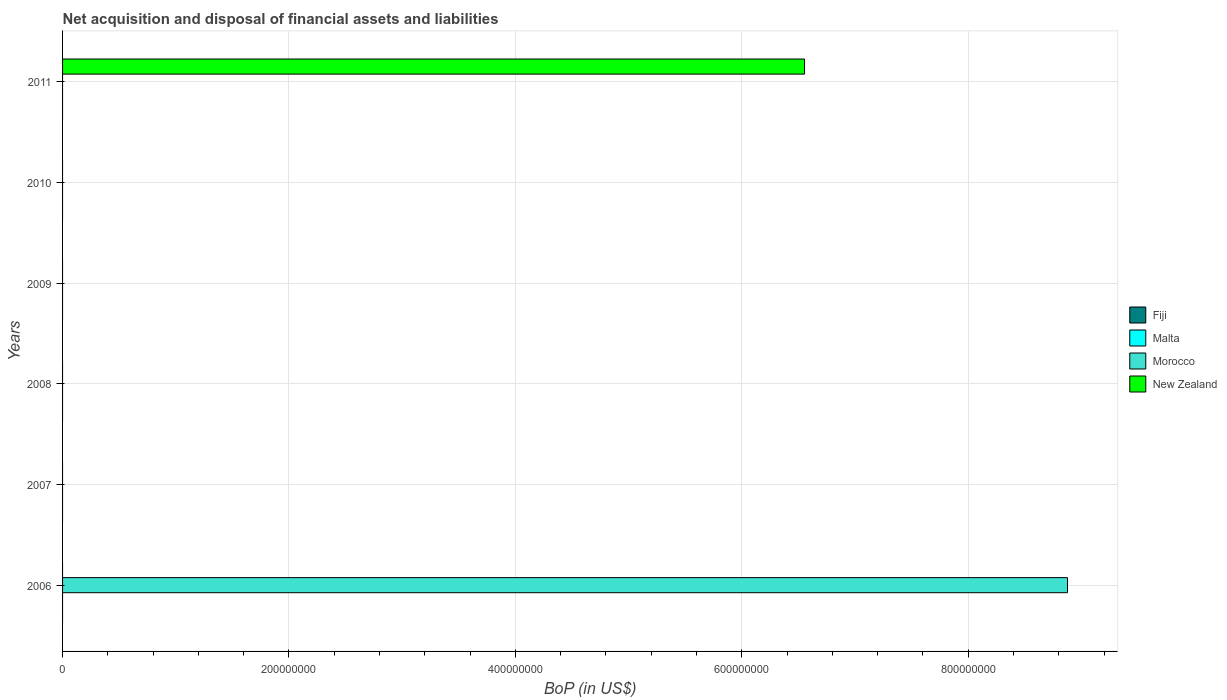How many different coloured bars are there?
Provide a succinct answer. 2. Are the number of bars per tick equal to the number of legend labels?
Offer a terse response. No. How many bars are there on the 6th tick from the top?
Provide a succinct answer. 1. Across all years, what is the maximum Balance of Payments in Morocco?
Your answer should be compact. 8.88e+08. Across all years, what is the minimum Balance of Payments in Morocco?
Offer a very short reply. 0. What is the total Balance of Payments in Morocco in the graph?
Your answer should be compact. 8.88e+08. What is the difference between the Balance of Payments in Morocco in 2011 and the Balance of Payments in Fiji in 2008?
Offer a very short reply. 0. What is the average Balance of Payments in Fiji per year?
Offer a very short reply. 0. In how many years, is the Balance of Payments in Malta greater than 840000000 US$?
Offer a terse response. 0. What is the difference between the highest and the lowest Balance of Payments in New Zealand?
Keep it short and to the point. 6.55e+08. What is the difference between two consecutive major ticks on the X-axis?
Your answer should be very brief. 2.00e+08. Does the graph contain grids?
Your answer should be compact. Yes. How many legend labels are there?
Make the answer very short. 4. What is the title of the graph?
Provide a succinct answer. Net acquisition and disposal of financial assets and liabilities. What is the label or title of the X-axis?
Your answer should be very brief. BoP (in US$). What is the label or title of the Y-axis?
Provide a succinct answer. Years. What is the BoP (in US$) in Fiji in 2006?
Ensure brevity in your answer.  0. What is the BoP (in US$) in Malta in 2006?
Your answer should be very brief. 0. What is the BoP (in US$) in Morocco in 2006?
Make the answer very short. 8.88e+08. What is the BoP (in US$) in New Zealand in 2006?
Offer a very short reply. 0. What is the BoP (in US$) in Malta in 2007?
Offer a very short reply. 0. What is the BoP (in US$) of Fiji in 2008?
Your response must be concise. 0. What is the BoP (in US$) of New Zealand in 2008?
Your answer should be very brief. 0. What is the BoP (in US$) of Malta in 2009?
Offer a terse response. 0. What is the BoP (in US$) in Morocco in 2009?
Give a very brief answer. 0. What is the BoP (in US$) of New Zealand in 2009?
Offer a terse response. 0. What is the BoP (in US$) in Fiji in 2010?
Provide a succinct answer. 0. What is the BoP (in US$) of Morocco in 2010?
Offer a very short reply. 0. What is the BoP (in US$) in Morocco in 2011?
Make the answer very short. 0. What is the BoP (in US$) in New Zealand in 2011?
Give a very brief answer. 6.55e+08. Across all years, what is the maximum BoP (in US$) of Morocco?
Offer a very short reply. 8.88e+08. Across all years, what is the maximum BoP (in US$) in New Zealand?
Offer a very short reply. 6.55e+08. Across all years, what is the minimum BoP (in US$) in Morocco?
Make the answer very short. 0. Across all years, what is the minimum BoP (in US$) of New Zealand?
Your answer should be compact. 0. What is the total BoP (in US$) of Morocco in the graph?
Make the answer very short. 8.88e+08. What is the total BoP (in US$) of New Zealand in the graph?
Your response must be concise. 6.55e+08. What is the difference between the BoP (in US$) in Morocco in 2006 and the BoP (in US$) in New Zealand in 2011?
Ensure brevity in your answer.  2.32e+08. What is the average BoP (in US$) in Malta per year?
Your answer should be compact. 0. What is the average BoP (in US$) in Morocco per year?
Make the answer very short. 1.48e+08. What is the average BoP (in US$) of New Zealand per year?
Give a very brief answer. 1.09e+08. What is the difference between the highest and the lowest BoP (in US$) in Morocco?
Provide a succinct answer. 8.88e+08. What is the difference between the highest and the lowest BoP (in US$) in New Zealand?
Give a very brief answer. 6.55e+08. 